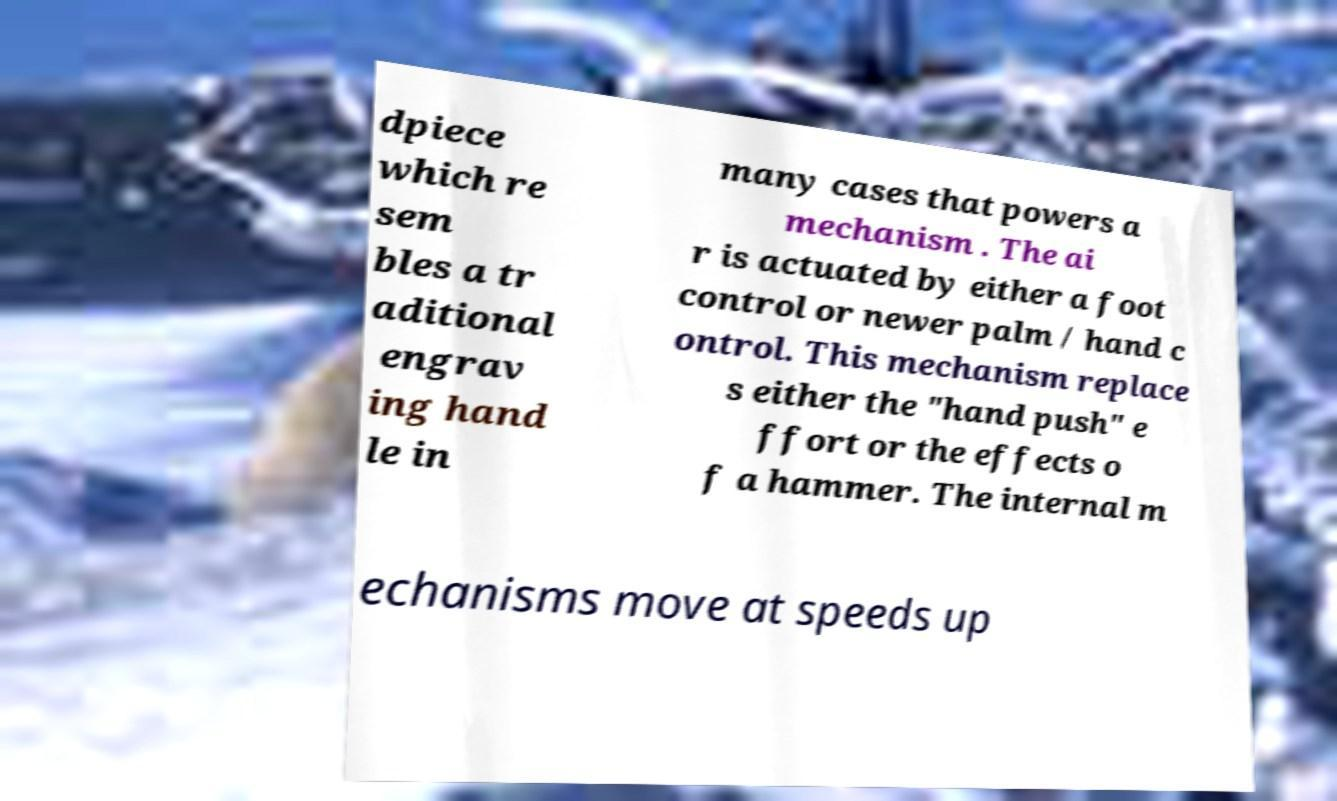I need the written content from this picture converted into text. Can you do that? dpiece which re sem bles a tr aditional engrav ing hand le in many cases that powers a mechanism . The ai r is actuated by either a foot control or newer palm / hand c ontrol. This mechanism replace s either the "hand push" e ffort or the effects o f a hammer. The internal m echanisms move at speeds up 